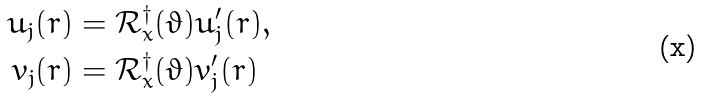<formula> <loc_0><loc_0><loc_500><loc_500>u _ { j } ( r ) & = \mathcal { R } ^ { \dag } _ { x } ( \vartheta ) u ^ { \prime } _ { j } ( r ) , \\ v _ { j } ( r ) & = \mathcal { R } ^ { \dag } _ { x } ( \vartheta ) v ^ { \prime } _ { j } ( r )</formula> 